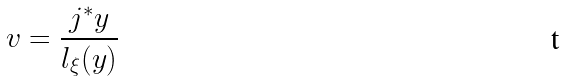<formula> <loc_0><loc_0><loc_500><loc_500>v = \frac { j ^ { \ast } y } { l _ { \xi } ( y ) }</formula> 